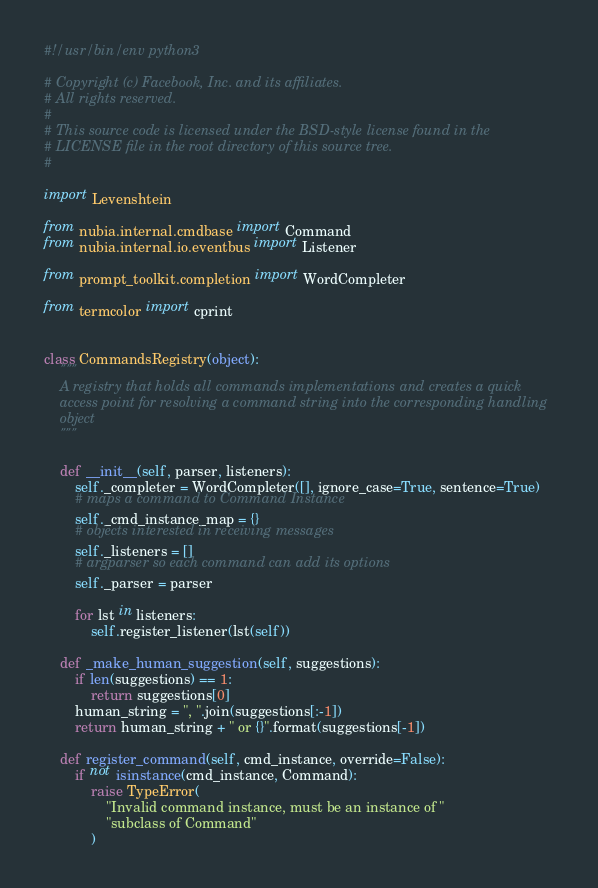Convert code to text. <code><loc_0><loc_0><loc_500><loc_500><_Python_>#!/usr/bin/env python3

# Copyright (c) Facebook, Inc. and its affiliates.
# All rights reserved.
#
# This source code is licensed under the BSD-style license found in the
# LICENSE file in the root directory of this source tree.
#

import Levenshtein

from nubia.internal.cmdbase import Command
from nubia.internal.io.eventbus import Listener

from prompt_toolkit.completion import WordCompleter

from termcolor import cprint


class CommandsRegistry(object):
    """
    A registry that holds all commands implementations and creates a quick
    access point for resolving a command string into the corresponding handling
    object
    """

    def __init__(self, parser, listeners):
        self._completer = WordCompleter([], ignore_case=True, sentence=True)
        # maps a command to Command Instance
        self._cmd_instance_map = {}
        # objects interested in receiving messages
        self._listeners = []
        # argparser so each command can add its options
        self._parser = parser

        for lst in listeners:
            self.register_listener(lst(self))

    def _make_human_suggestion(self, suggestions):
        if len(suggestions) == 1:
            return suggestions[0]
        human_string = ", ".join(suggestions[:-1])
        return human_string + " or {}".format(suggestions[-1])

    def register_command(self, cmd_instance, override=False):
        if not isinstance(cmd_instance, Command):
            raise TypeError(
                "Invalid command instance, must be an instance of "
                "subclass of Command"
            )
</code> 